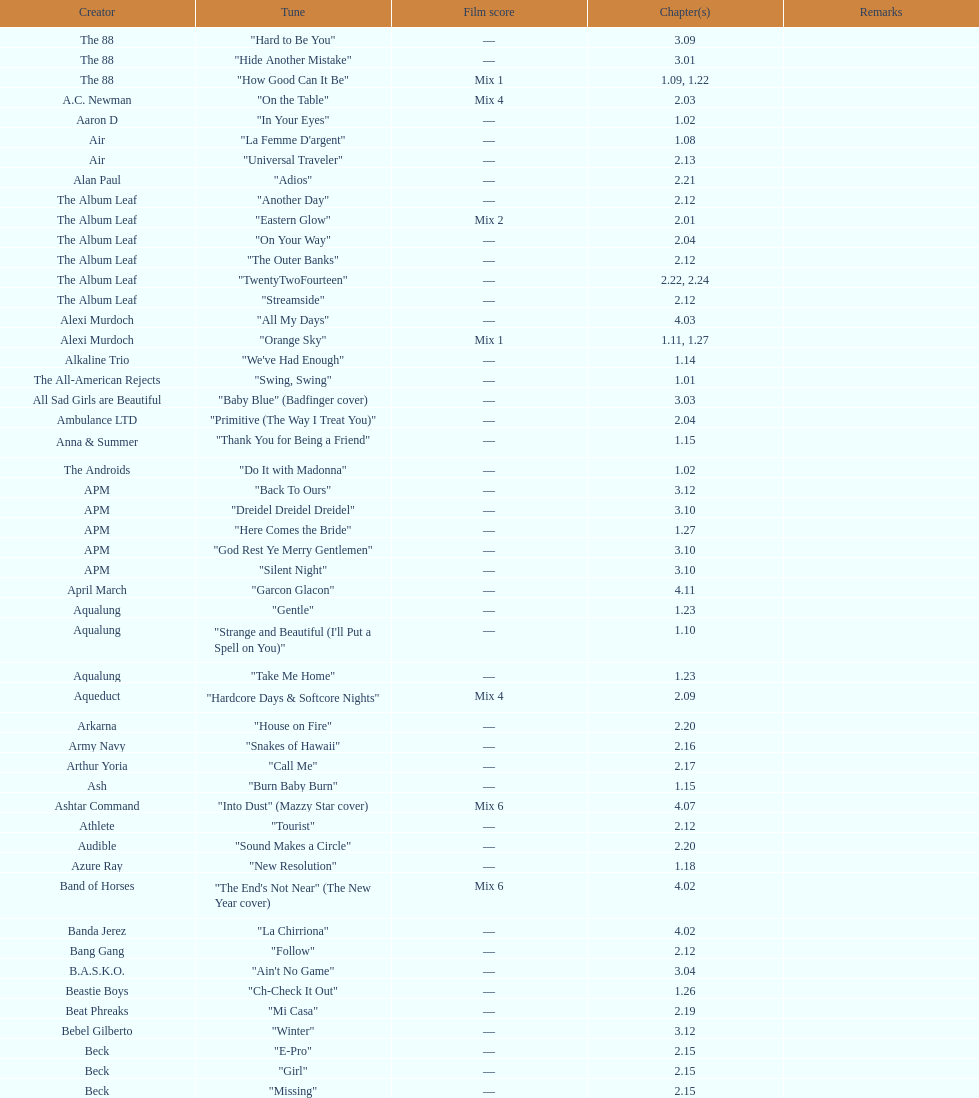How many episodes are below 2.00? 27. 